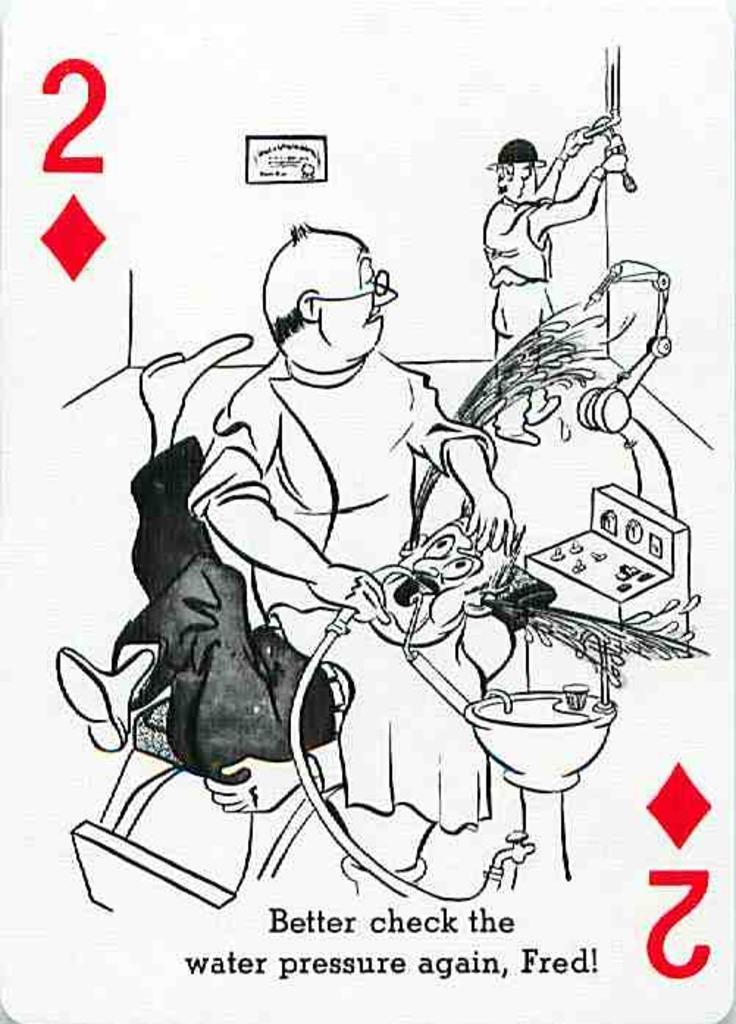Please provide a concise description of this image. This might be a poster, in this image in the center there is one person sitting and one person is lying on a bed. And there is one wash basin and some machines text, and some other objects. 